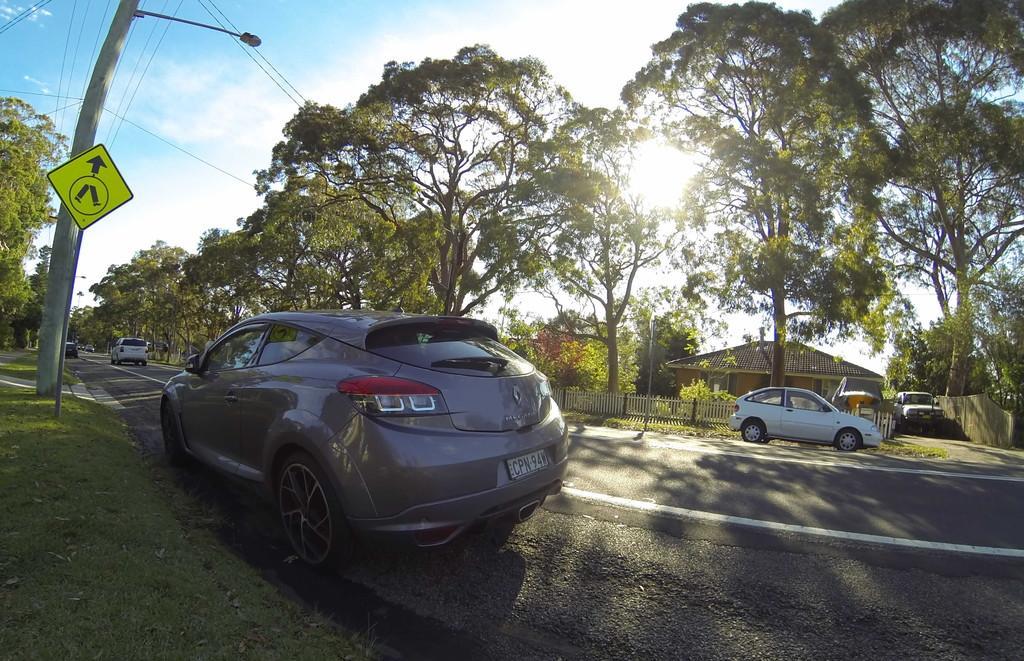Can you describe this image briefly? In this image, we can see road in between trees. There is a pole on the left side of the image. There is a shelter house in the middle of the image. There are cars on the road. In the background of the image, there is a sky. 